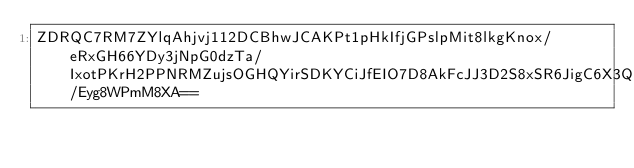<code> <loc_0><loc_0><loc_500><loc_500><_SML_>ZDRQC7RM7ZYlqAhjvj112DCBhwJCAKPt1pHkIfjGPslpMit8lkgKnox/eRxGH66YDy3jNpG0dzTa/IxotPKrH2PPNRMZujsOGHQYirSDKYCiJfEIO7D8AkFcJJ3D2S8xSR6JigC6X3QFRvdwPh8cYxIdHD7ABRv7y35d5KGco624M1FlHyCdqfPg7tHMYgAmeM/Eyg8WPmM8XA==</code> 